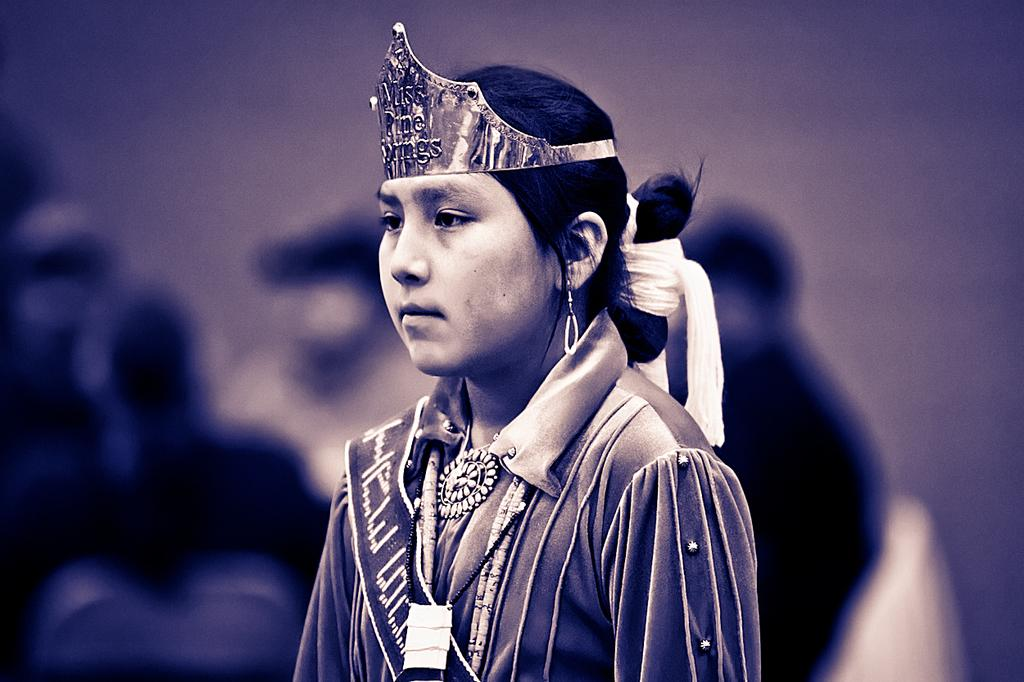Who is the main subject in the image? There is a girl in the image. What is the girl wearing on her head? The girl is wearing a crown on her head. Can you describe the background of the image? The background of the image is blurred. What type of root can be seen growing from the girl's crown in the image? There is no root growing from the girl's crown in the image. What material is the lead used for the crown made of in the image? The image does not specify the material used for the crown, and there is no mention of lead. 